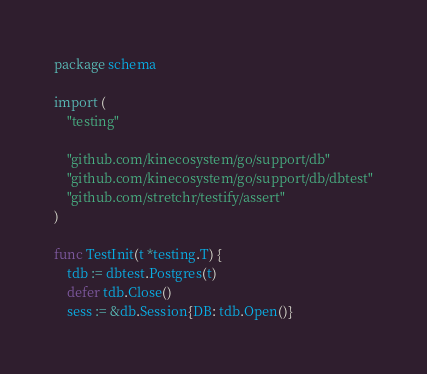Convert code to text. <code><loc_0><loc_0><loc_500><loc_500><_Go_>package schema

import (
	"testing"

	"github.com/kinecosystem/go/support/db"
	"github.com/kinecosystem/go/support/db/dbtest"
	"github.com/stretchr/testify/assert"
)

func TestInit(t *testing.T) {
	tdb := dbtest.Postgres(t)
	defer tdb.Close()
	sess := &db.Session{DB: tdb.Open()}
</code> 